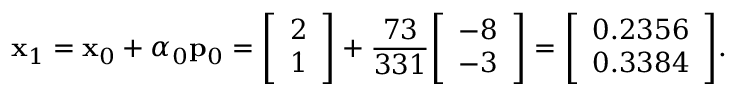<formula> <loc_0><loc_0><loc_500><loc_500>x _ { 1 } = x _ { 0 } + \alpha _ { 0 } p _ { 0 } = { \left [ \begin{array} { l } { 2 } \\ { 1 } \end{array} \right ] } + { \frac { 7 3 } { 3 3 1 } } { \left [ \begin{array} { l } { - 8 } \\ { - 3 } \end{array} \right ] } = { \left [ \begin{array} { l } { 0 . 2 3 5 6 } \\ { 0 . 3 3 8 4 } \end{array} \right ] } .</formula> 